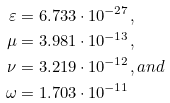<formula> <loc_0><loc_0><loc_500><loc_500>\varepsilon & = 6 . 7 3 3 \cdot 1 0 ^ { - 2 7 } , \\ \mu & = 3 . 9 8 1 \cdot 1 0 ^ { - 1 3 } , \\ \nu & = 3 . 2 1 9 \cdot 1 0 ^ { - 1 2 } , a n d \\ \omega & = 1 . 7 0 3 \cdot 1 0 ^ { - 1 1 }</formula> 